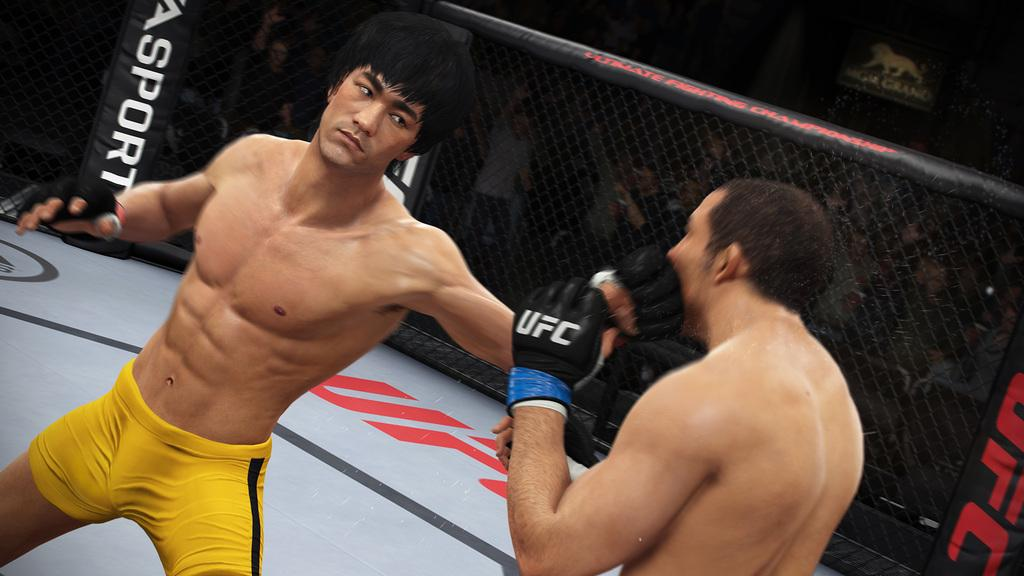<image>
Provide a brief description of the given image. A boxer throws a punch at another boxer who is wearing a UFC glove. 